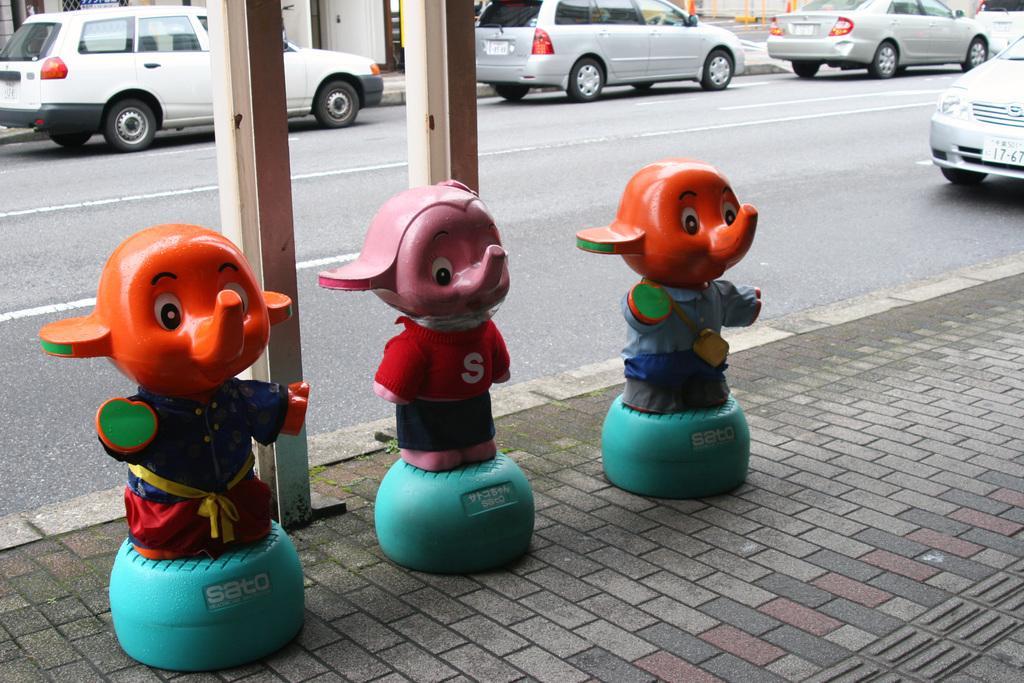Can you describe this image briefly? In this image I can see three toys to the side of the road. These toys are colorful. On the road there are many vehicles which are in white and ash color. In the background I can see the buildings. 